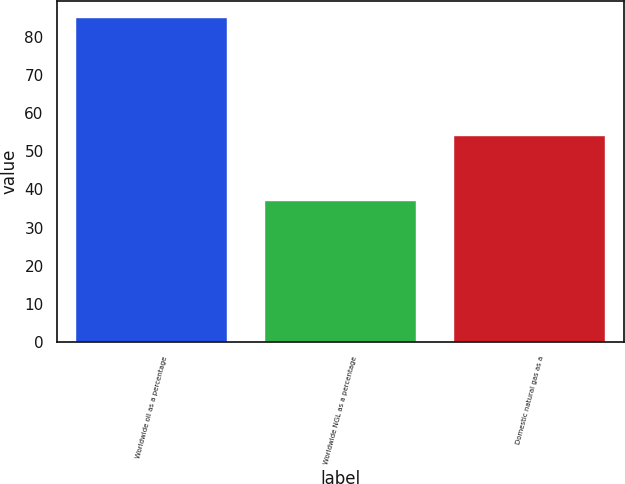Convert chart to OTSL. <chart><loc_0><loc_0><loc_500><loc_500><bar_chart><fcel>Worldwide oil as a percentage<fcel>Worldwide NGL as a percentage<fcel>Domestic natural gas as a<nl><fcel>85<fcel>37<fcel>54<nl></chart> 